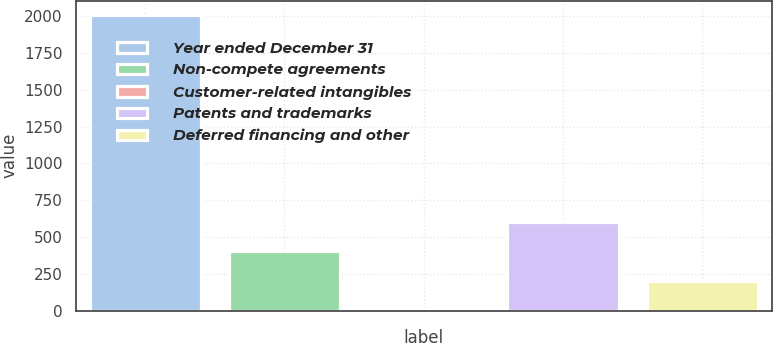<chart> <loc_0><loc_0><loc_500><loc_500><bar_chart><fcel>Year ended December 31<fcel>Non-compete agreements<fcel>Customer-related intangibles<fcel>Patents and trademarks<fcel>Deferred financing and other<nl><fcel>2005<fcel>403.88<fcel>3.6<fcel>604.02<fcel>203.74<nl></chart> 